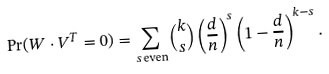Convert formula to latex. <formula><loc_0><loc_0><loc_500><loc_500>\Pr ( W \cdot V ^ { T } = 0 ) = \sum _ { s \, \text {even} } \binom { k } { s } \left ( \frac { d } { n } \right ) ^ { s } \left ( 1 - \frac { d } { n } \right ) ^ { k - s } .</formula> 